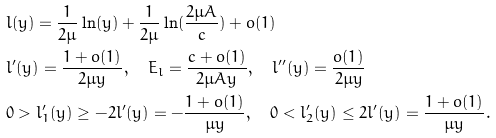<formula> <loc_0><loc_0><loc_500><loc_500>& l ( y ) = \frac { 1 } { 2 \mu } \ln ( y ) + \frac { 1 } { 2 \mu } \ln ( \frac { 2 \mu A } { c } ) + o ( 1 ) \\ & l ^ { \prime } ( y ) = \frac { 1 + o ( 1 ) } { 2 \mu y } , \quad E _ { l } = \frac { c + o ( 1 ) } { 2 \mu A y } , \quad l ^ { \prime \prime } ( y ) = \frac { o ( 1 ) } { 2 \mu y } \\ & 0 > l _ { 1 } ^ { \prime } ( y ) \geq - 2 l ^ { \prime } ( y ) = - \frac { 1 + o ( 1 ) } { \mu y } , \quad 0 < l _ { 2 } ^ { \prime } ( y ) \leq 2 l ^ { \prime } ( y ) = \frac { 1 + o ( 1 ) } { \mu y } .</formula> 